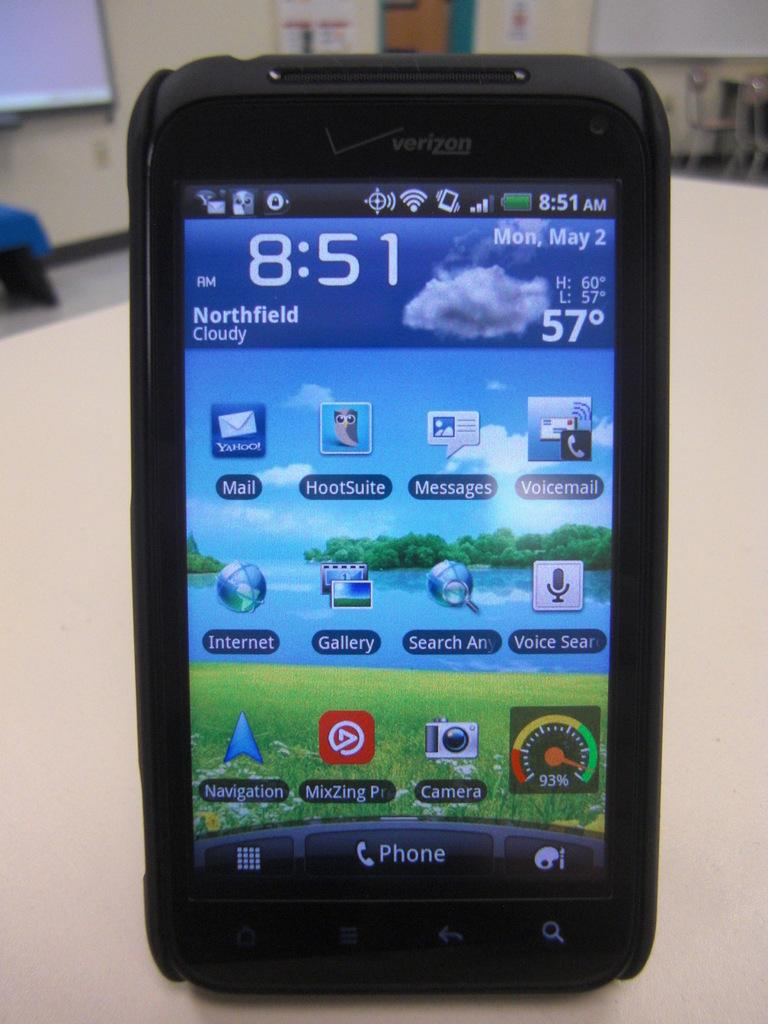<image>
Give a short and clear explanation of the subsequent image. A cell phone display shows the time is 8:51 AM and the temperature is 57 degrees. 